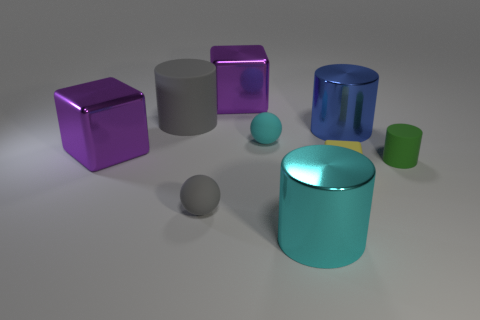Subtract all yellow matte blocks. How many blocks are left? 2 Subtract all cyan cylinders. How many cylinders are left? 3 Subtract all spheres. How many objects are left? 7 Subtract all blue spheres. Subtract all red cylinders. How many spheres are left? 2 Subtract all purple cylinders. How many cyan balls are left? 1 Subtract all tiny green objects. Subtract all gray matte things. How many objects are left? 6 Add 1 blue cylinders. How many blue cylinders are left? 2 Add 6 purple metallic blocks. How many purple metallic blocks exist? 8 Subtract 0 blue cubes. How many objects are left? 9 Subtract 2 cylinders. How many cylinders are left? 2 